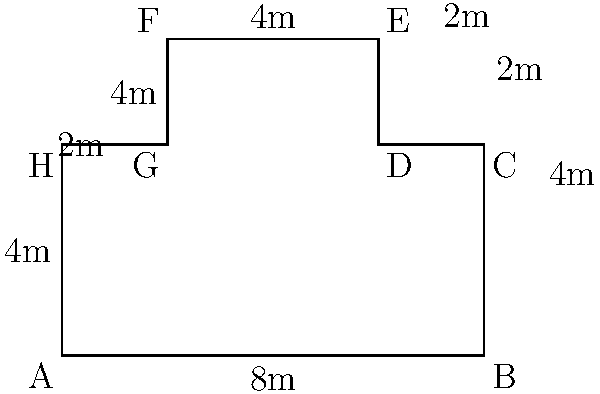As a single parent, you're planning to fence an irregularly shaped playground for your child's safety. The playground's shape is shown in the diagram above. Calculate the perimeter of the playground to determine how much fencing material you'll need. Round your answer to the nearest meter. Let's approach this step-by-step:

1) First, let's identify the lengths of each side:
   AB = 8m
   BC = 4m
   CD = 2m
   DE = 2m
   EF = 4m
   FG = 4m
   GH = 2m
   HA = 4m

2) To find the perimeter, we need to add up all these lengths:

   Perimeter = AB + BC + CD + DE + EF + FG + GH + HA
             = 8 + 4 + 2 + 2 + 4 + 4 + 2 + 4

3) Let's sum these up:
   
   Perimeter = 30m

4) The question asks to round to the nearest meter, but 30 is already a whole number, so no rounding is necessary.

As a wise parent, you now know exactly how much fencing material you'll need to ensure your child's safety in the playground.
Answer: 30m 